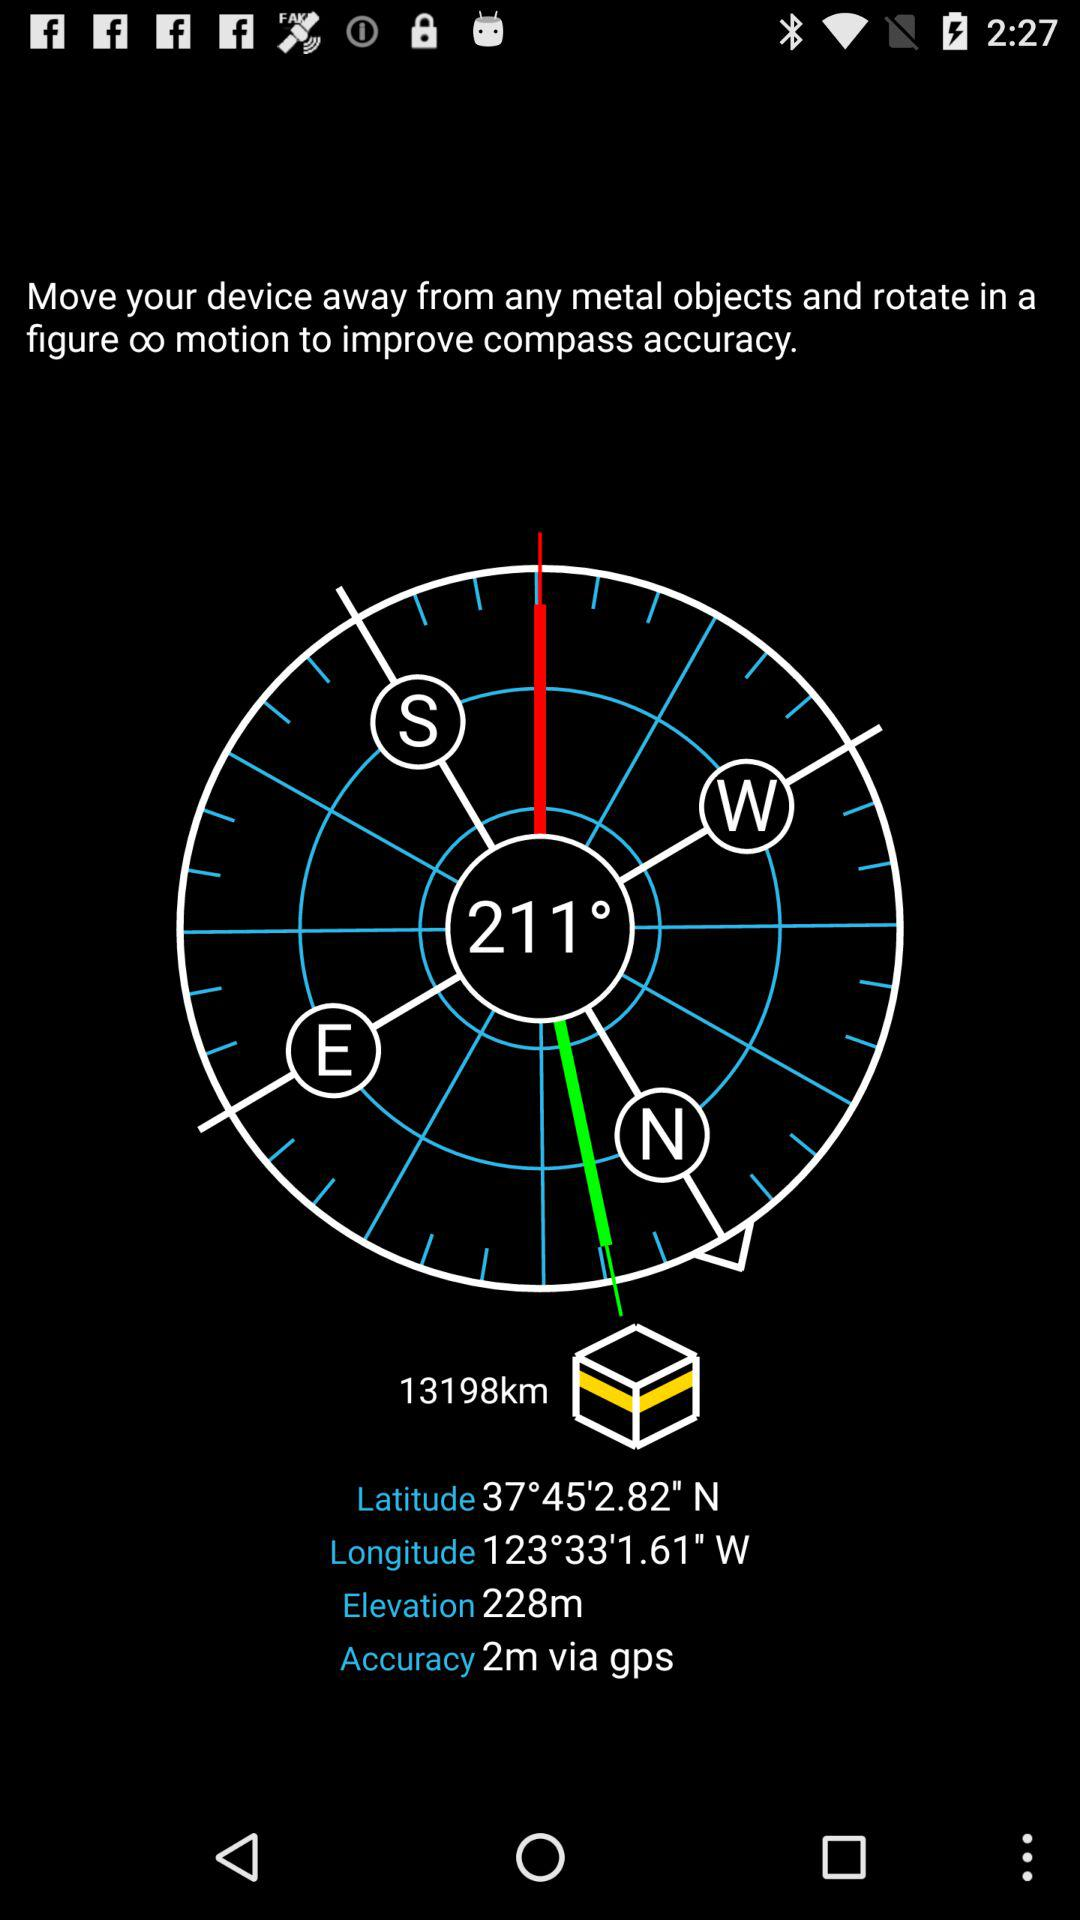What is the latitude? The latitude is 37°45'2.82" N. 